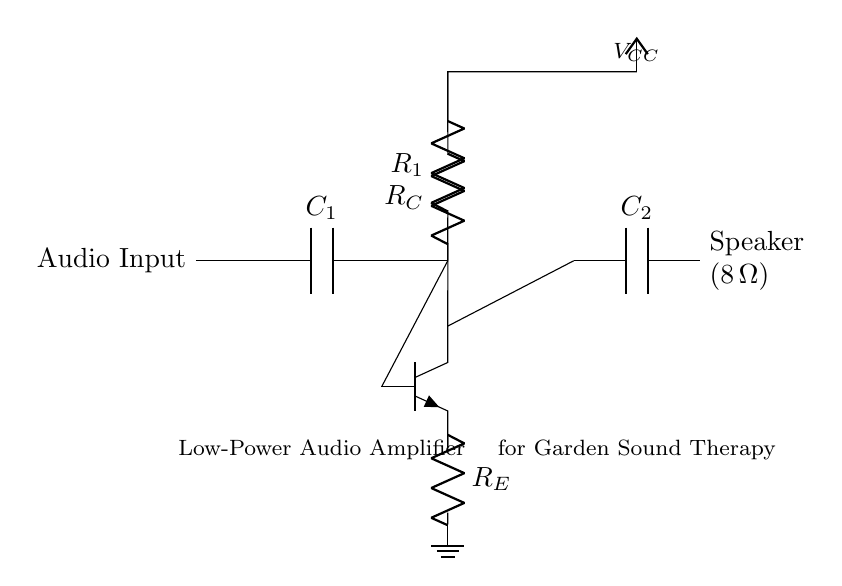What is the type of input for this amplifier circuit? The input is labeled as "Audio Input," indicating that it is an audio signal being fed into the amplifier.
Answer: Audio Input What does the component labeled R1 do in the circuit? R1 is a resistor connected in the biasing network for the transistor, helping to set the correct operating point for the transistor.
Answer: Biasing What is the value of the load represented by the speaker? The speaker is labeled as having a resistance of 8 ohms, which is its load value that the amplifier drives.
Answer: 8 ohms What type of transistor is used in this amplifier? The diagram shows an NPN transistor, as indicated by the npn notation next to the symbol in the circuit.
Answer: NPN How does the capacitor C1 function in this circuit? C1 serves to block any DC voltage while allowing the AC audio signal to pass through, enabling audio signals to be amplified without DC components affecting the circuit.
Answer: Coupling What is the purpose of the resistor RE in this amplifier circuit? RE is an emitter resistor that provides stability for the transistor's operation, helping to set the gain and improve linearity in the amplifier’s performance.
Answer: Stability What is the supply voltage represented as VCC in the diagram? VCC represents the supply voltage connected to the collector of the transistor, which is essential for powering the amplifier circuit.
Answer: Not specified 